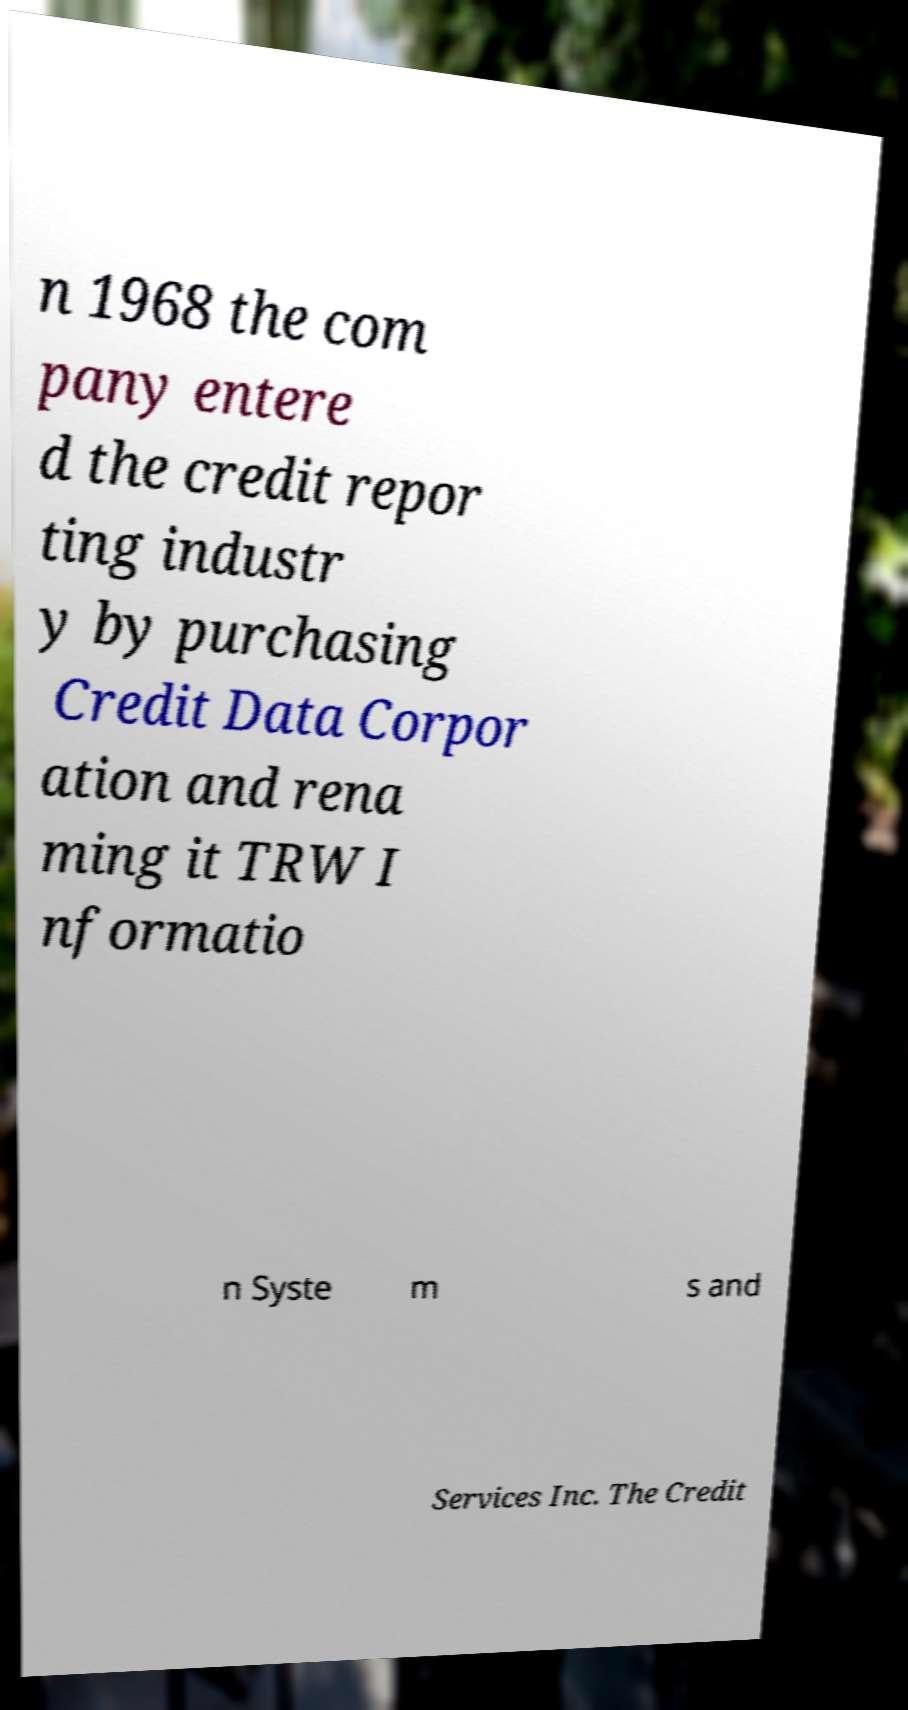There's text embedded in this image that I need extracted. Can you transcribe it verbatim? n 1968 the com pany entere d the credit repor ting industr y by purchasing Credit Data Corpor ation and rena ming it TRW I nformatio n Syste m s and Services Inc. The Credit 